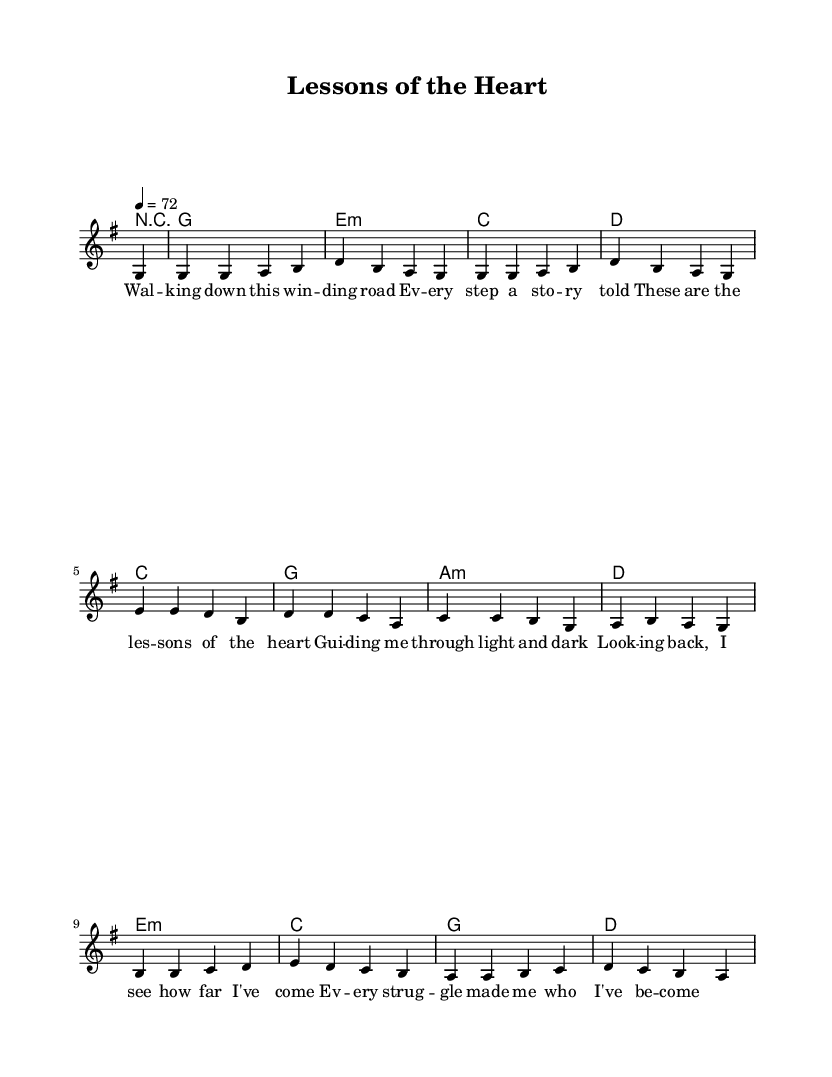What is the key signature of this music? The key signature is G major, which contains an F# in its scale. This can be identified from the presence of the sharp on the staff.
Answer: G major What is the time signature of this music? The time signature is 4/4, which is indicated by the notation in the beginning of the sheet music. Each measure contains four beats, and it is a common time signature.
Answer: 4/4 What is the tempo marking? The tempo marking is 72 beats per minute, which is specified in the tempo indication at the beginning. This means that each quarter note gets 72 beats in a minute.
Answer: 72 How many measures are in the melody? To determine the number of measures, we count the vertical lines that separate the music into sections. There are a total of 12 measures in the melody line.
Answer: 12 What chord follows the first measure? The first measure has a rest, and the chord that follows it is G major, identified by the chord symbol placed above the first melody note.
Answer: G What is the lyrical theme of the song based on the sheet music? The lyrical phrases reflect personal experiences and growth, as indicated by lines discussing walking, stories, and struggles that shape a person. The words suggest introspection and learning from past experiences.
Answer: Lessons of the heart What type of style is reflected in this composition? The composition represents an acoustic-driven pop anthem style, typical of the 1990s, as it uses a simple structure, relatable lyrics, and a melody that is catchy and straightforward.
Answer: Acoustic-driven pop 